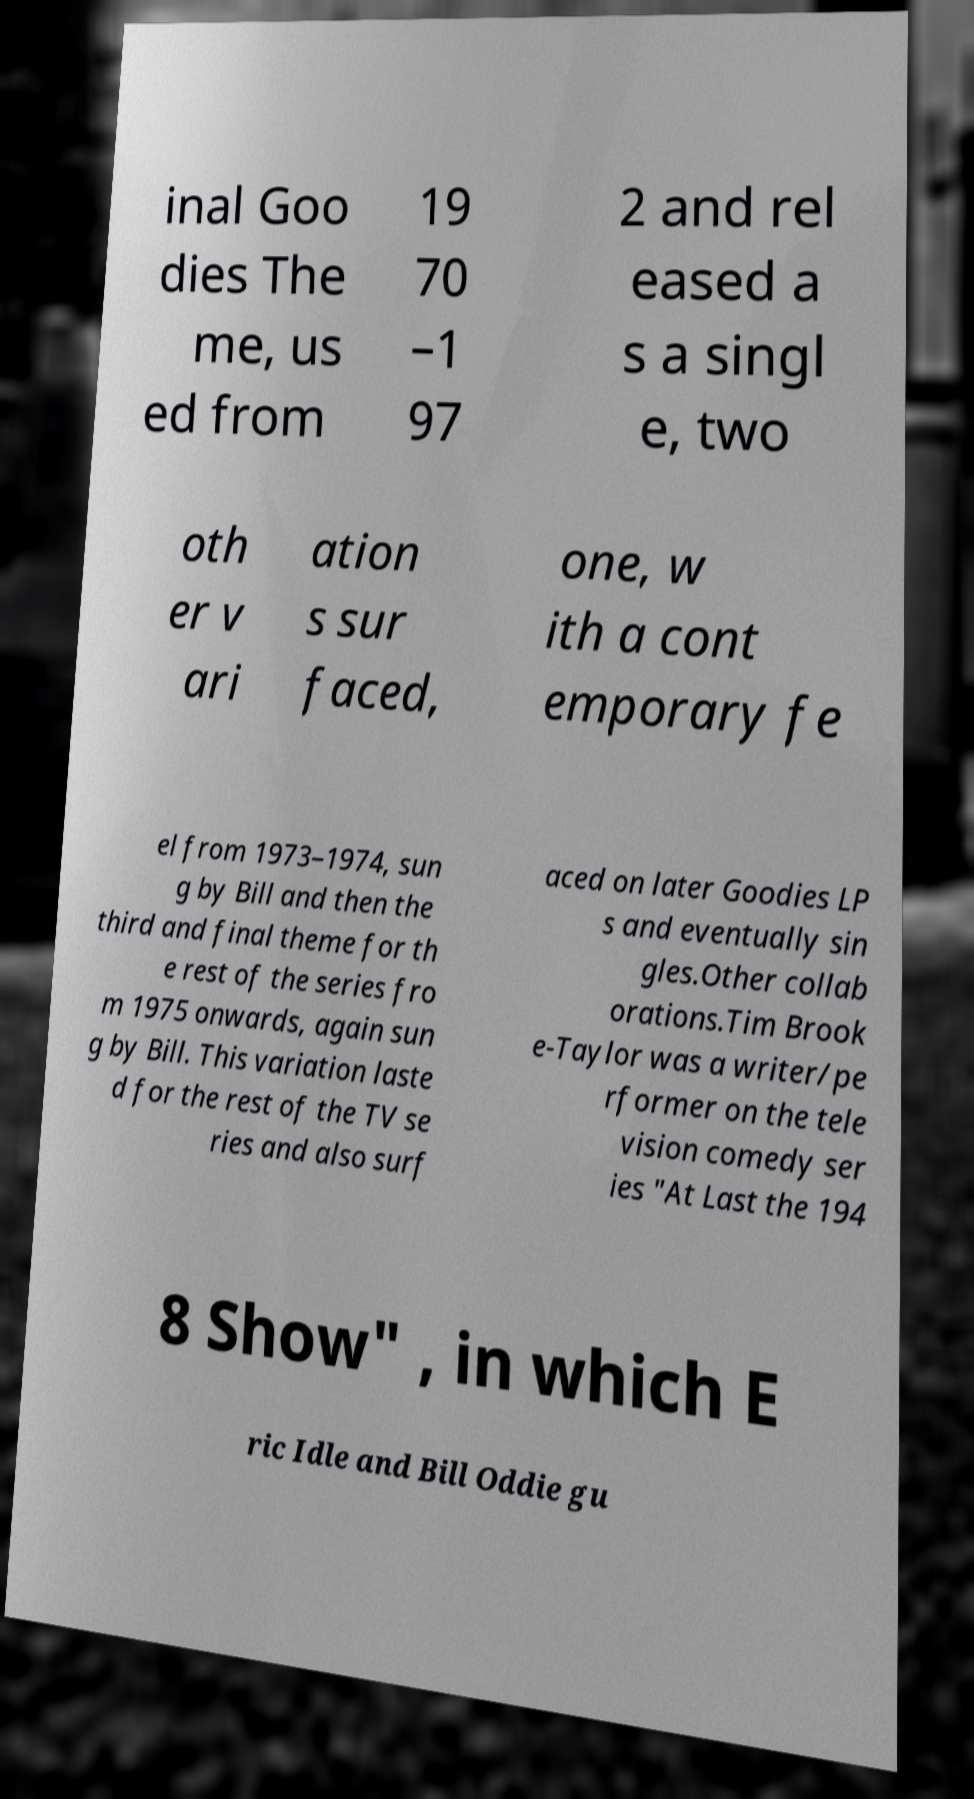There's text embedded in this image that I need extracted. Can you transcribe it verbatim? inal Goo dies The me, us ed from 19 70 –1 97 2 and rel eased a s a singl e, two oth er v ari ation s sur faced, one, w ith a cont emporary fe el from 1973–1974, sun g by Bill and then the third and final theme for th e rest of the series fro m 1975 onwards, again sun g by Bill. This variation laste d for the rest of the TV se ries and also surf aced on later Goodies LP s and eventually sin gles.Other collab orations.Tim Brook e-Taylor was a writer/pe rformer on the tele vision comedy ser ies "At Last the 194 8 Show" , in which E ric Idle and Bill Oddie gu 